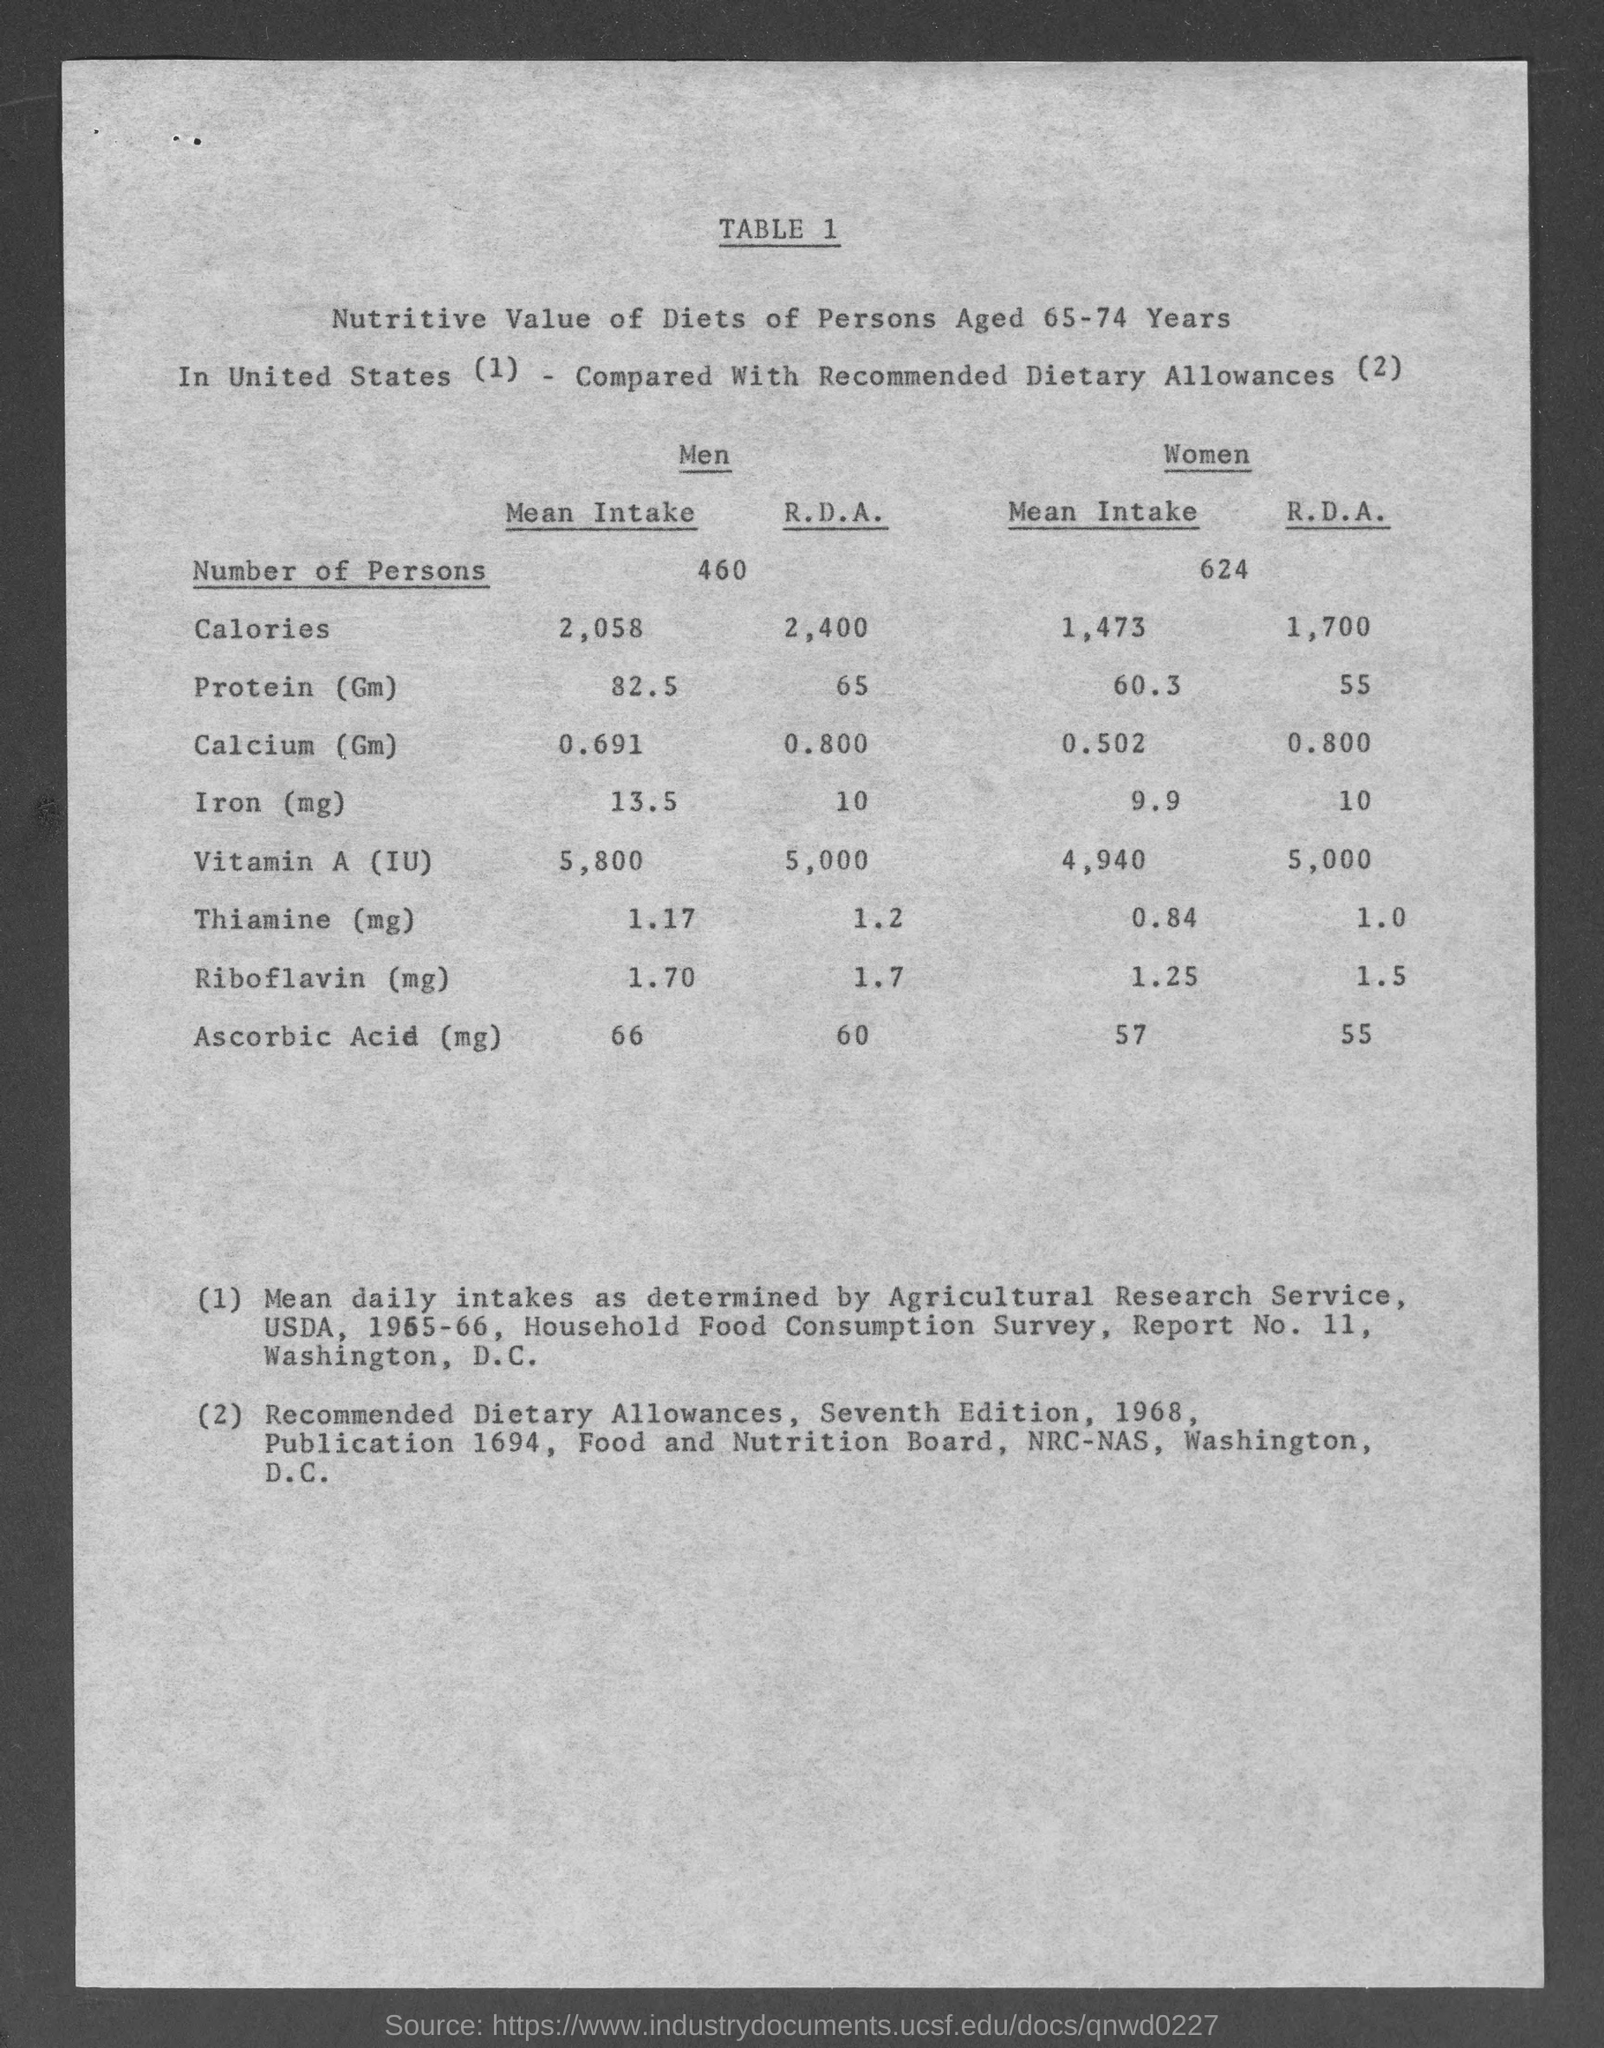Identify some key points in this picture. There were 624 women. The average daily intake of calcium for women is 0.502 grams. There were 460 men. 